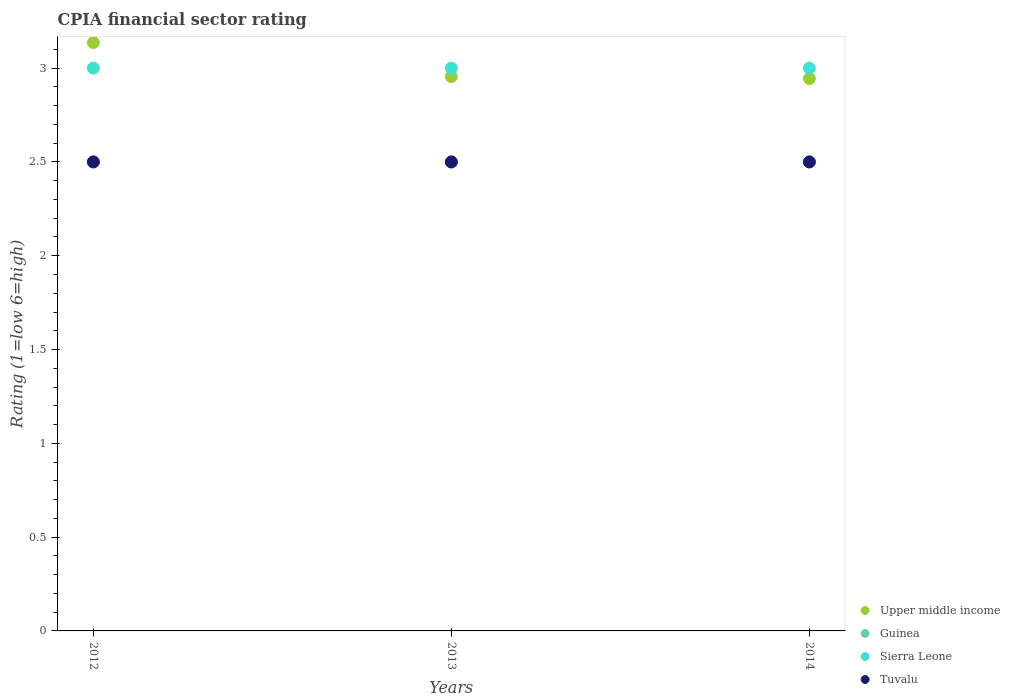Is the number of dotlines equal to the number of legend labels?
Your answer should be very brief. Yes. Across all years, what is the maximum CPIA rating in Tuvalu?
Keep it short and to the point. 2.5. In which year was the CPIA rating in Upper middle income minimum?
Provide a short and direct response. 2014. What is the total CPIA rating in Tuvalu in the graph?
Offer a terse response. 7.5. What is the difference between the CPIA rating in Upper middle income in 2013 and the CPIA rating in Guinea in 2014?
Your answer should be very brief. 0.45. What is the ratio of the CPIA rating in Upper middle income in 2013 to that in 2014?
Your answer should be compact. 1. Is the CPIA rating in Guinea in 2013 less than that in 2014?
Give a very brief answer. No. Is the difference between the CPIA rating in Tuvalu in 2013 and 2014 greater than the difference between the CPIA rating in Sierra Leone in 2013 and 2014?
Your answer should be very brief. No. What is the difference between the highest and the second highest CPIA rating in Upper middle income?
Your response must be concise. 0.18. Is the sum of the CPIA rating in Sierra Leone in 2012 and 2014 greater than the maximum CPIA rating in Guinea across all years?
Make the answer very short. Yes. Is it the case that in every year, the sum of the CPIA rating in Guinea and CPIA rating in Tuvalu  is greater than the CPIA rating in Upper middle income?
Your answer should be compact. Yes. Does the CPIA rating in Guinea monotonically increase over the years?
Offer a terse response. No. Is the CPIA rating in Upper middle income strictly greater than the CPIA rating in Guinea over the years?
Make the answer very short. Yes. What is the difference between two consecutive major ticks on the Y-axis?
Provide a short and direct response. 0.5. Does the graph contain any zero values?
Offer a terse response. No. Does the graph contain grids?
Provide a short and direct response. No. Where does the legend appear in the graph?
Offer a very short reply. Bottom right. How many legend labels are there?
Offer a terse response. 4. What is the title of the graph?
Offer a terse response. CPIA financial sector rating. What is the label or title of the X-axis?
Provide a short and direct response. Years. What is the Rating (1=low 6=high) in Upper middle income in 2012?
Ensure brevity in your answer.  3.14. What is the Rating (1=low 6=high) in Sierra Leone in 2012?
Give a very brief answer. 3. What is the Rating (1=low 6=high) in Upper middle income in 2013?
Offer a very short reply. 2.95. What is the Rating (1=low 6=high) in Guinea in 2013?
Ensure brevity in your answer.  2.5. What is the Rating (1=low 6=high) of Sierra Leone in 2013?
Offer a very short reply. 3. What is the Rating (1=low 6=high) of Tuvalu in 2013?
Make the answer very short. 2.5. What is the Rating (1=low 6=high) of Upper middle income in 2014?
Give a very brief answer. 2.94. What is the Rating (1=low 6=high) in Guinea in 2014?
Give a very brief answer. 2.5. What is the Rating (1=low 6=high) in Sierra Leone in 2014?
Give a very brief answer. 3. Across all years, what is the maximum Rating (1=low 6=high) of Upper middle income?
Your answer should be compact. 3.14. Across all years, what is the maximum Rating (1=low 6=high) of Guinea?
Offer a very short reply. 2.5. Across all years, what is the minimum Rating (1=low 6=high) in Upper middle income?
Offer a terse response. 2.94. Across all years, what is the minimum Rating (1=low 6=high) in Guinea?
Offer a very short reply. 2.5. Across all years, what is the minimum Rating (1=low 6=high) in Tuvalu?
Give a very brief answer. 2.5. What is the total Rating (1=low 6=high) of Upper middle income in the graph?
Provide a succinct answer. 9.04. What is the difference between the Rating (1=low 6=high) in Upper middle income in 2012 and that in 2013?
Ensure brevity in your answer.  0.18. What is the difference between the Rating (1=low 6=high) of Guinea in 2012 and that in 2013?
Your answer should be very brief. 0. What is the difference between the Rating (1=low 6=high) in Tuvalu in 2012 and that in 2013?
Offer a terse response. 0. What is the difference between the Rating (1=low 6=high) of Upper middle income in 2012 and that in 2014?
Offer a terse response. 0.19. What is the difference between the Rating (1=low 6=high) in Guinea in 2012 and that in 2014?
Provide a short and direct response. 0. What is the difference between the Rating (1=low 6=high) of Upper middle income in 2013 and that in 2014?
Offer a terse response. 0.01. What is the difference between the Rating (1=low 6=high) of Guinea in 2013 and that in 2014?
Give a very brief answer. 0. What is the difference between the Rating (1=low 6=high) in Sierra Leone in 2013 and that in 2014?
Provide a succinct answer. 0. What is the difference between the Rating (1=low 6=high) in Tuvalu in 2013 and that in 2014?
Offer a very short reply. 0. What is the difference between the Rating (1=low 6=high) of Upper middle income in 2012 and the Rating (1=low 6=high) of Guinea in 2013?
Your response must be concise. 0.64. What is the difference between the Rating (1=low 6=high) of Upper middle income in 2012 and the Rating (1=low 6=high) of Sierra Leone in 2013?
Offer a terse response. 0.14. What is the difference between the Rating (1=low 6=high) of Upper middle income in 2012 and the Rating (1=low 6=high) of Tuvalu in 2013?
Your answer should be compact. 0.64. What is the difference between the Rating (1=low 6=high) in Upper middle income in 2012 and the Rating (1=low 6=high) in Guinea in 2014?
Your answer should be very brief. 0.64. What is the difference between the Rating (1=low 6=high) of Upper middle income in 2012 and the Rating (1=low 6=high) of Sierra Leone in 2014?
Ensure brevity in your answer.  0.14. What is the difference between the Rating (1=low 6=high) of Upper middle income in 2012 and the Rating (1=low 6=high) of Tuvalu in 2014?
Your answer should be compact. 0.64. What is the difference between the Rating (1=low 6=high) of Guinea in 2012 and the Rating (1=low 6=high) of Sierra Leone in 2014?
Keep it short and to the point. -0.5. What is the difference between the Rating (1=low 6=high) in Guinea in 2012 and the Rating (1=low 6=high) in Tuvalu in 2014?
Ensure brevity in your answer.  0. What is the difference between the Rating (1=low 6=high) in Sierra Leone in 2012 and the Rating (1=low 6=high) in Tuvalu in 2014?
Your answer should be very brief. 0.5. What is the difference between the Rating (1=low 6=high) in Upper middle income in 2013 and the Rating (1=low 6=high) in Guinea in 2014?
Your answer should be compact. 0.45. What is the difference between the Rating (1=low 6=high) of Upper middle income in 2013 and the Rating (1=low 6=high) of Sierra Leone in 2014?
Provide a succinct answer. -0.05. What is the difference between the Rating (1=low 6=high) of Upper middle income in 2013 and the Rating (1=low 6=high) of Tuvalu in 2014?
Ensure brevity in your answer.  0.45. What is the difference between the Rating (1=low 6=high) in Guinea in 2013 and the Rating (1=low 6=high) in Tuvalu in 2014?
Provide a succinct answer. 0. What is the average Rating (1=low 6=high) of Upper middle income per year?
Keep it short and to the point. 3.01. What is the average Rating (1=low 6=high) in Sierra Leone per year?
Your answer should be compact. 3. What is the average Rating (1=low 6=high) of Tuvalu per year?
Provide a succinct answer. 2.5. In the year 2012, what is the difference between the Rating (1=low 6=high) in Upper middle income and Rating (1=low 6=high) in Guinea?
Offer a terse response. 0.64. In the year 2012, what is the difference between the Rating (1=low 6=high) in Upper middle income and Rating (1=low 6=high) in Sierra Leone?
Provide a short and direct response. 0.14. In the year 2012, what is the difference between the Rating (1=low 6=high) of Upper middle income and Rating (1=low 6=high) of Tuvalu?
Your answer should be very brief. 0.64. In the year 2012, what is the difference between the Rating (1=low 6=high) of Guinea and Rating (1=low 6=high) of Tuvalu?
Offer a terse response. 0. In the year 2013, what is the difference between the Rating (1=low 6=high) of Upper middle income and Rating (1=low 6=high) of Guinea?
Offer a terse response. 0.45. In the year 2013, what is the difference between the Rating (1=low 6=high) of Upper middle income and Rating (1=low 6=high) of Sierra Leone?
Provide a succinct answer. -0.05. In the year 2013, what is the difference between the Rating (1=low 6=high) in Upper middle income and Rating (1=low 6=high) in Tuvalu?
Give a very brief answer. 0.45. In the year 2013, what is the difference between the Rating (1=low 6=high) of Guinea and Rating (1=low 6=high) of Tuvalu?
Keep it short and to the point. 0. In the year 2014, what is the difference between the Rating (1=low 6=high) in Upper middle income and Rating (1=low 6=high) in Guinea?
Provide a short and direct response. 0.44. In the year 2014, what is the difference between the Rating (1=low 6=high) in Upper middle income and Rating (1=low 6=high) in Sierra Leone?
Your answer should be very brief. -0.06. In the year 2014, what is the difference between the Rating (1=low 6=high) of Upper middle income and Rating (1=low 6=high) of Tuvalu?
Your answer should be compact. 0.44. In the year 2014, what is the difference between the Rating (1=low 6=high) of Guinea and Rating (1=low 6=high) of Tuvalu?
Keep it short and to the point. 0. In the year 2014, what is the difference between the Rating (1=low 6=high) in Sierra Leone and Rating (1=low 6=high) in Tuvalu?
Provide a short and direct response. 0.5. What is the ratio of the Rating (1=low 6=high) in Upper middle income in 2012 to that in 2013?
Ensure brevity in your answer.  1.06. What is the ratio of the Rating (1=low 6=high) of Tuvalu in 2012 to that in 2013?
Your response must be concise. 1. What is the ratio of the Rating (1=low 6=high) in Upper middle income in 2012 to that in 2014?
Your answer should be very brief. 1.07. What is the ratio of the Rating (1=low 6=high) of Guinea in 2012 to that in 2014?
Keep it short and to the point. 1. What is the ratio of the Rating (1=low 6=high) of Tuvalu in 2013 to that in 2014?
Ensure brevity in your answer.  1. What is the difference between the highest and the second highest Rating (1=low 6=high) of Upper middle income?
Ensure brevity in your answer.  0.18. What is the difference between the highest and the second highest Rating (1=low 6=high) of Guinea?
Keep it short and to the point. 0. What is the difference between the highest and the second highest Rating (1=low 6=high) of Sierra Leone?
Your answer should be very brief. 0. What is the difference between the highest and the lowest Rating (1=low 6=high) in Upper middle income?
Give a very brief answer. 0.19. What is the difference between the highest and the lowest Rating (1=low 6=high) in Sierra Leone?
Keep it short and to the point. 0. 